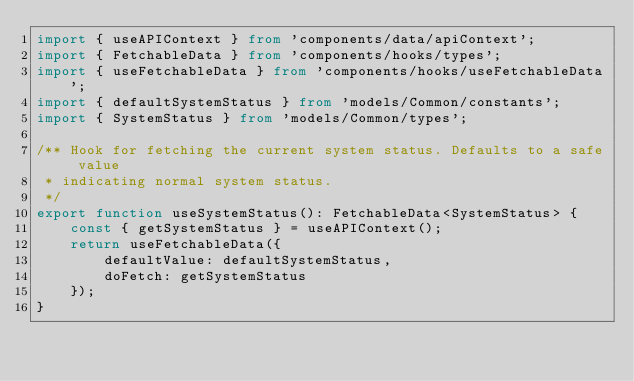<code> <loc_0><loc_0><loc_500><loc_500><_TypeScript_>import { useAPIContext } from 'components/data/apiContext';
import { FetchableData } from 'components/hooks/types';
import { useFetchableData } from 'components/hooks/useFetchableData';
import { defaultSystemStatus } from 'models/Common/constants';
import { SystemStatus } from 'models/Common/types';

/** Hook for fetching the current system status. Defaults to a safe value
 * indicating normal system status.
 */
export function useSystemStatus(): FetchableData<SystemStatus> {
    const { getSystemStatus } = useAPIContext();
    return useFetchableData({
        defaultValue: defaultSystemStatus,
        doFetch: getSystemStatus
    });
}
</code> 